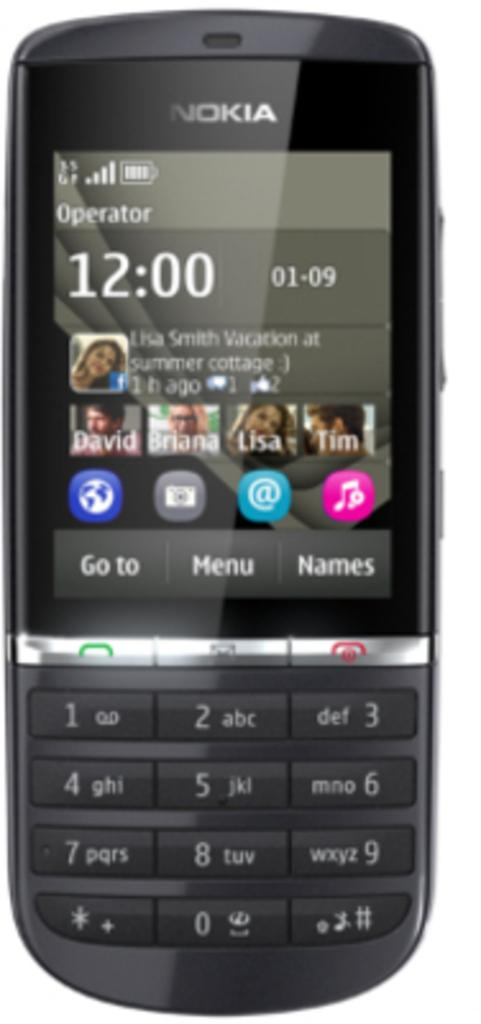Provide a one-sentence caption for the provided image. A Nokia phone with the time of 12:00 on 01-09. 